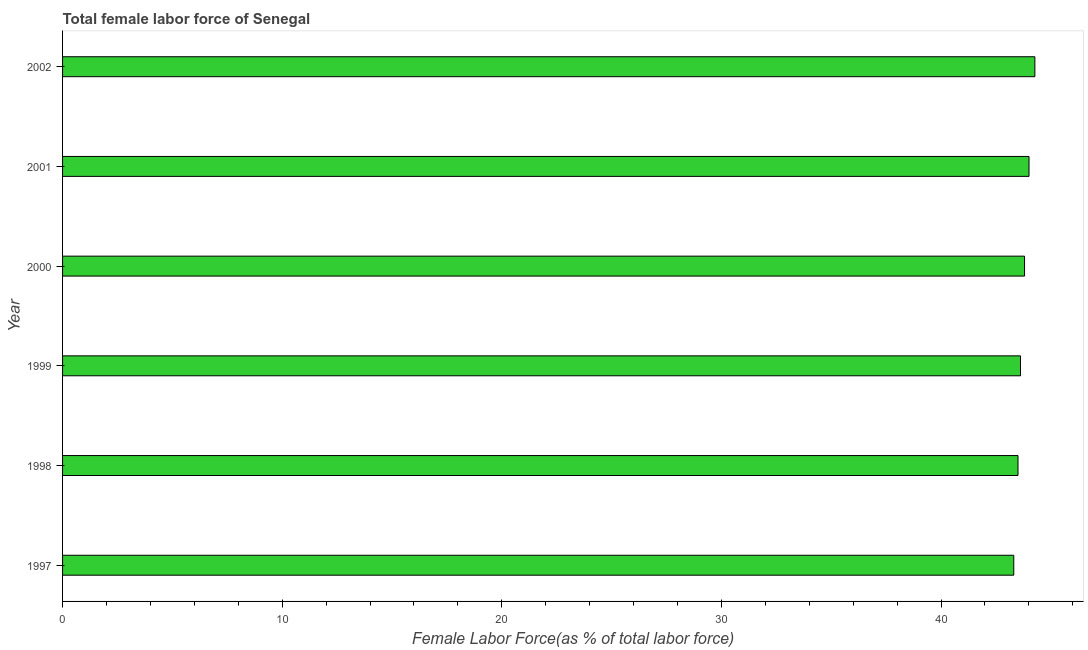What is the title of the graph?
Your answer should be very brief. Total female labor force of Senegal. What is the label or title of the X-axis?
Your answer should be compact. Female Labor Force(as % of total labor force). What is the label or title of the Y-axis?
Offer a terse response. Year. What is the total female labor force in 2001?
Provide a short and direct response. 44.01. Across all years, what is the maximum total female labor force?
Keep it short and to the point. 44.27. Across all years, what is the minimum total female labor force?
Keep it short and to the point. 43.31. In which year was the total female labor force maximum?
Keep it short and to the point. 2002. In which year was the total female labor force minimum?
Offer a terse response. 1997. What is the sum of the total female labor force?
Your answer should be very brief. 262.52. What is the difference between the total female labor force in 1999 and 2002?
Your answer should be very brief. -0.66. What is the average total female labor force per year?
Give a very brief answer. 43.75. What is the median total female labor force?
Provide a succinct answer. 43.71. Is the difference between the total female labor force in 1998 and 1999 greater than the difference between any two years?
Your answer should be very brief. No. What is the difference between the highest and the second highest total female labor force?
Keep it short and to the point. 0.27. What is the difference between the highest and the lowest total female labor force?
Your response must be concise. 0.96. In how many years, is the total female labor force greater than the average total female labor force taken over all years?
Make the answer very short. 3. What is the difference between two consecutive major ticks on the X-axis?
Keep it short and to the point. 10. What is the Female Labor Force(as % of total labor force) of 1997?
Offer a very short reply. 43.31. What is the Female Labor Force(as % of total labor force) in 1998?
Provide a short and direct response. 43.51. What is the Female Labor Force(as % of total labor force) of 1999?
Your answer should be very brief. 43.62. What is the Female Labor Force(as % of total labor force) of 2000?
Your answer should be very brief. 43.8. What is the Female Labor Force(as % of total labor force) in 2001?
Give a very brief answer. 44.01. What is the Female Labor Force(as % of total labor force) of 2002?
Make the answer very short. 44.27. What is the difference between the Female Labor Force(as % of total labor force) in 1997 and 1998?
Provide a short and direct response. -0.19. What is the difference between the Female Labor Force(as % of total labor force) in 1997 and 1999?
Provide a short and direct response. -0.31. What is the difference between the Female Labor Force(as % of total labor force) in 1997 and 2000?
Ensure brevity in your answer.  -0.49. What is the difference between the Female Labor Force(as % of total labor force) in 1997 and 2001?
Provide a short and direct response. -0.69. What is the difference between the Female Labor Force(as % of total labor force) in 1997 and 2002?
Keep it short and to the point. -0.96. What is the difference between the Female Labor Force(as % of total labor force) in 1998 and 1999?
Offer a terse response. -0.11. What is the difference between the Female Labor Force(as % of total labor force) in 1998 and 2000?
Keep it short and to the point. -0.3. What is the difference between the Female Labor Force(as % of total labor force) in 1998 and 2001?
Offer a terse response. -0.5. What is the difference between the Female Labor Force(as % of total labor force) in 1998 and 2002?
Your answer should be very brief. -0.77. What is the difference between the Female Labor Force(as % of total labor force) in 1999 and 2000?
Keep it short and to the point. -0.18. What is the difference between the Female Labor Force(as % of total labor force) in 1999 and 2001?
Your response must be concise. -0.39. What is the difference between the Female Labor Force(as % of total labor force) in 1999 and 2002?
Your answer should be compact. -0.65. What is the difference between the Female Labor Force(as % of total labor force) in 2000 and 2001?
Your answer should be compact. -0.2. What is the difference between the Female Labor Force(as % of total labor force) in 2000 and 2002?
Offer a very short reply. -0.47. What is the difference between the Female Labor Force(as % of total labor force) in 2001 and 2002?
Offer a terse response. -0.27. What is the ratio of the Female Labor Force(as % of total labor force) in 1997 to that in 1999?
Offer a very short reply. 0.99. What is the ratio of the Female Labor Force(as % of total labor force) in 1997 to that in 2002?
Your answer should be very brief. 0.98. What is the ratio of the Female Labor Force(as % of total labor force) in 1998 to that in 2001?
Make the answer very short. 0.99. What is the ratio of the Female Labor Force(as % of total labor force) in 1998 to that in 2002?
Your answer should be compact. 0.98. What is the ratio of the Female Labor Force(as % of total labor force) in 1999 to that in 2000?
Give a very brief answer. 1. What is the ratio of the Female Labor Force(as % of total labor force) in 1999 to that in 2001?
Give a very brief answer. 0.99. What is the ratio of the Female Labor Force(as % of total labor force) in 1999 to that in 2002?
Offer a very short reply. 0.98. What is the ratio of the Female Labor Force(as % of total labor force) in 2000 to that in 2002?
Keep it short and to the point. 0.99. 